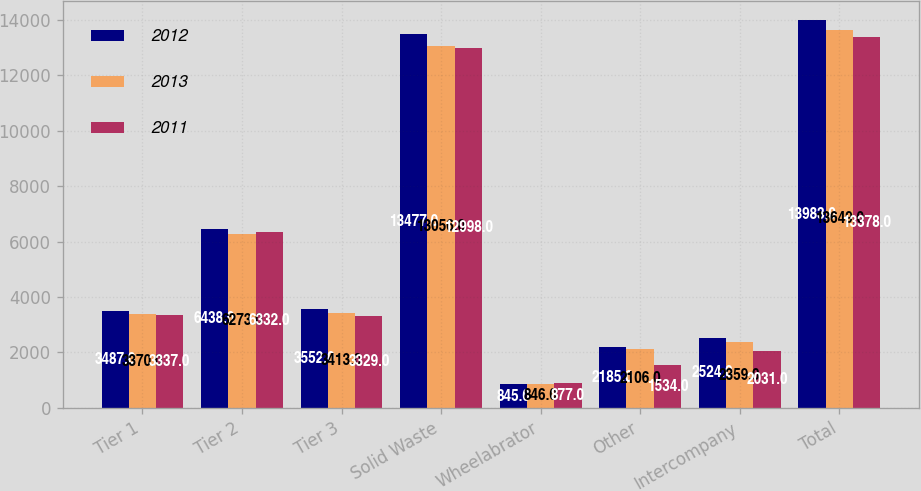Convert chart. <chart><loc_0><loc_0><loc_500><loc_500><stacked_bar_chart><ecel><fcel>Tier 1<fcel>Tier 2<fcel>Tier 3<fcel>Solid Waste<fcel>Wheelabrator<fcel>Other<fcel>Intercompany<fcel>Total<nl><fcel>2012<fcel>3487<fcel>6438<fcel>3552<fcel>13477<fcel>845<fcel>2185<fcel>2524<fcel>13983<nl><fcel>2013<fcel>3370<fcel>6273<fcel>3413<fcel>13056<fcel>846<fcel>2106<fcel>2359<fcel>13649<nl><fcel>2011<fcel>3337<fcel>6332<fcel>3329<fcel>12998<fcel>877<fcel>1534<fcel>2031<fcel>13378<nl></chart> 